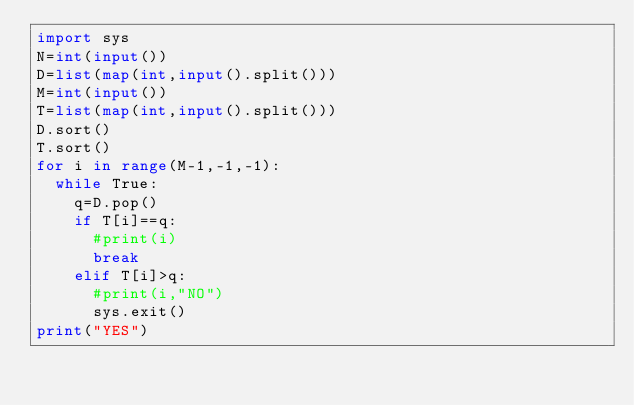Convert code to text. <code><loc_0><loc_0><loc_500><loc_500><_Python_>import sys
N=int(input())
D=list(map(int,input().split()))
M=int(input())
T=list(map(int,input().split()))
D.sort()
T.sort()
for i in range(M-1,-1,-1):
  while True:
    q=D.pop()
    if T[i]==q:
      #print(i)
      break
    elif T[i]>q:
      #print(i,"NO")
      sys.exit()
print("YES")</code> 